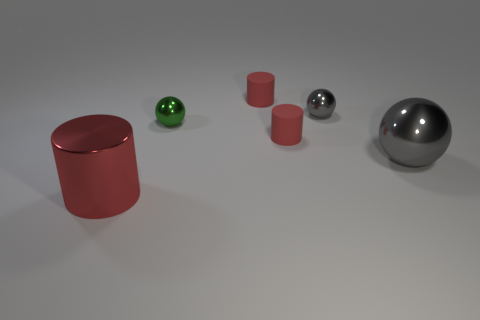What number of things are either gray spheres that are on the left side of the big gray metallic sphere or tiny gray metallic spheres?
Your answer should be compact. 1. There is a red rubber thing on the right side of the tiny cylinder that is behind the small gray ball; what is its shape?
Your response must be concise. Cylinder. Is there a shiny ball that has the same size as the red shiny thing?
Your answer should be compact. Yes. Are there more small yellow metallic cubes than gray shiny things?
Keep it short and to the point. No. Do the red thing that is on the left side of the tiny green metal sphere and the gray sphere left of the big gray object have the same size?
Make the answer very short. No. What number of objects are on the right side of the small gray metallic thing and in front of the big sphere?
Provide a short and direct response. 0. The large shiny thing that is the same shape as the tiny gray metal thing is what color?
Offer a terse response. Gray. Are there fewer small gray metallic things than big green things?
Ensure brevity in your answer.  No. There is a red metallic cylinder; is it the same size as the gray sphere to the left of the big gray metallic sphere?
Keep it short and to the point. No. The big metallic thing behind the red object that is in front of the large ball is what color?
Provide a succinct answer. Gray. 